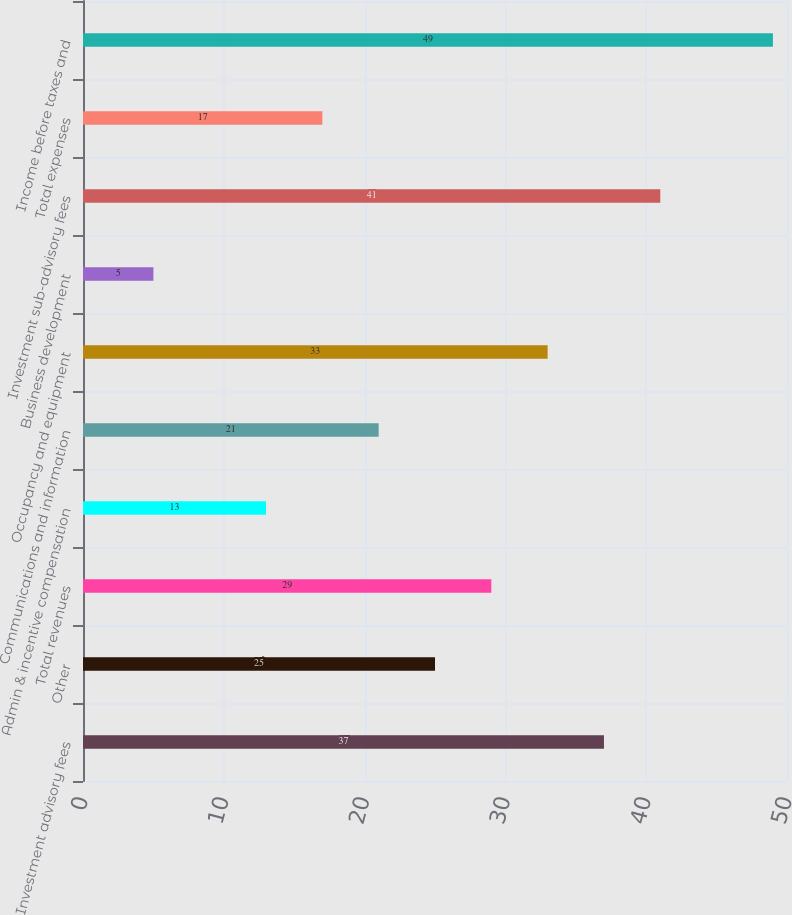Convert chart. <chart><loc_0><loc_0><loc_500><loc_500><bar_chart><fcel>Investment advisory fees<fcel>Other<fcel>Total revenues<fcel>Admin & incentive compensation<fcel>Communications and information<fcel>Occupancy and equipment<fcel>Business development<fcel>Investment sub-advisory fees<fcel>Total expenses<fcel>Income before taxes and<nl><fcel>37<fcel>25<fcel>29<fcel>13<fcel>21<fcel>33<fcel>5<fcel>41<fcel>17<fcel>49<nl></chart> 